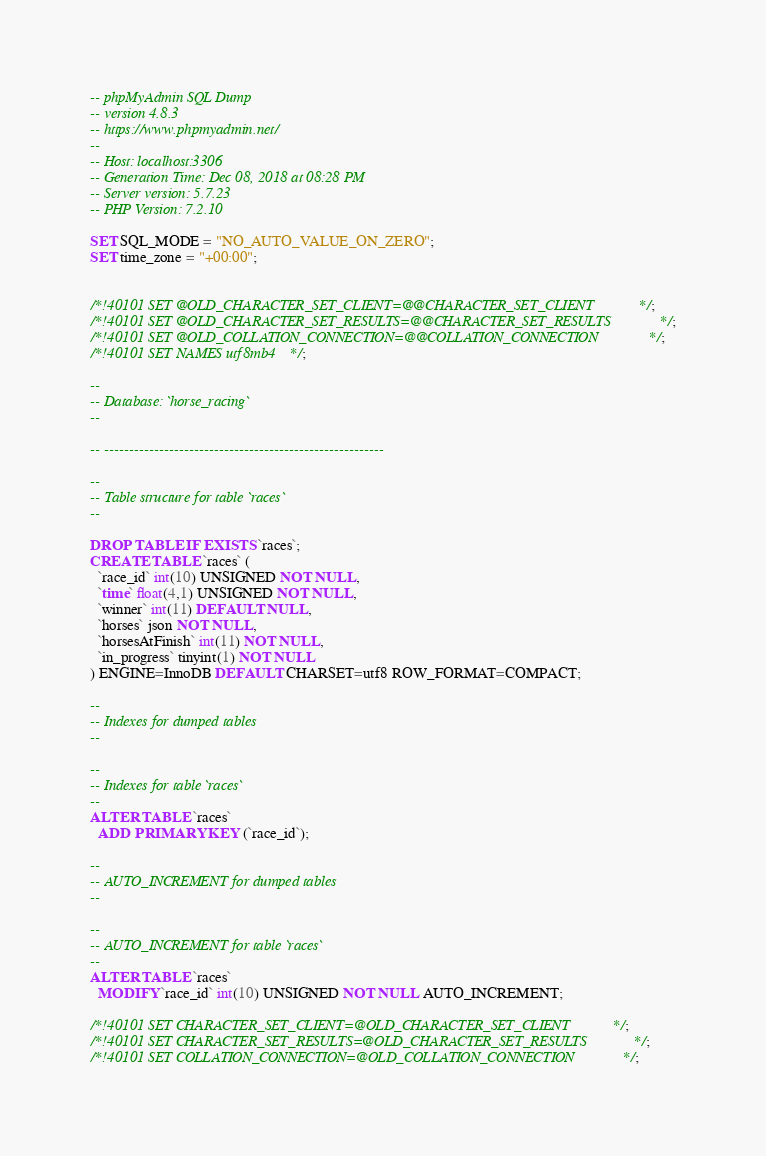<code> <loc_0><loc_0><loc_500><loc_500><_SQL_>-- phpMyAdmin SQL Dump
-- version 4.8.3
-- https://www.phpmyadmin.net/
--
-- Host: localhost:3306
-- Generation Time: Dec 08, 2018 at 08:28 PM
-- Server version: 5.7.23
-- PHP Version: 7.2.10

SET SQL_MODE = "NO_AUTO_VALUE_ON_ZERO";
SET time_zone = "+00:00";


/*!40101 SET @OLD_CHARACTER_SET_CLIENT=@@CHARACTER_SET_CLIENT */;
/*!40101 SET @OLD_CHARACTER_SET_RESULTS=@@CHARACTER_SET_RESULTS */;
/*!40101 SET @OLD_COLLATION_CONNECTION=@@COLLATION_CONNECTION */;
/*!40101 SET NAMES utf8mb4 */;

--
-- Database: `horse_racing`
--

-- --------------------------------------------------------

--
-- Table structure for table `races`
--

DROP TABLE IF EXISTS `races`;
CREATE TABLE `races` (
  `race_id` int(10) UNSIGNED NOT NULL,
  `time` float(4,1) UNSIGNED NOT NULL,
  `winner` int(11) DEFAULT NULL,
  `horses` json NOT NULL,
  `horsesAtFinish` int(11) NOT NULL,
  `in_progress` tinyint(1) NOT NULL
) ENGINE=InnoDB DEFAULT CHARSET=utf8 ROW_FORMAT=COMPACT;

--
-- Indexes for dumped tables
--

--
-- Indexes for table `races`
--
ALTER TABLE `races`
  ADD PRIMARY KEY (`race_id`);

--
-- AUTO_INCREMENT for dumped tables
--

--
-- AUTO_INCREMENT for table `races`
--
ALTER TABLE `races`
  MODIFY `race_id` int(10) UNSIGNED NOT NULL AUTO_INCREMENT;

/*!40101 SET CHARACTER_SET_CLIENT=@OLD_CHARACTER_SET_CLIENT */;
/*!40101 SET CHARACTER_SET_RESULTS=@OLD_CHARACTER_SET_RESULTS */;
/*!40101 SET COLLATION_CONNECTION=@OLD_COLLATION_CONNECTION */;
</code> 